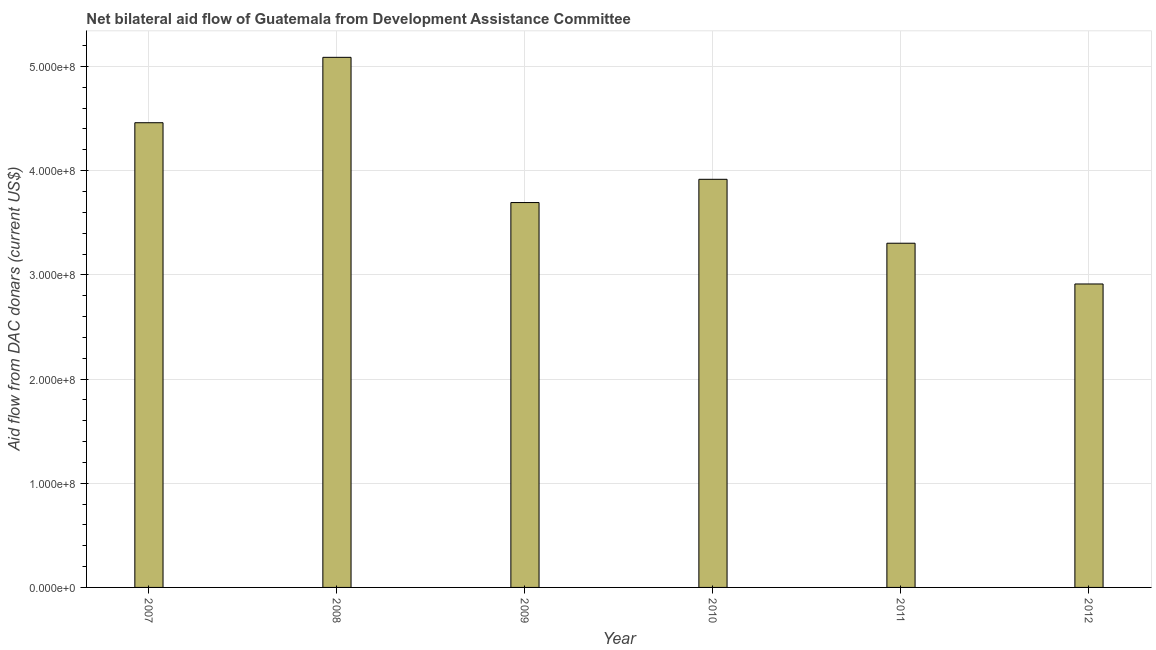What is the title of the graph?
Provide a succinct answer. Net bilateral aid flow of Guatemala from Development Assistance Committee. What is the label or title of the X-axis?
Your answer should be very brief. Year. What is the label or title of the Y-axis?
Offer a terse response. Aid flow from DAC donars (current US$). What is the net bilateral aid flows from dac donors in 2010?
Provide a short and direct response. 3.92e+08. Across all years, what is the maximum net bilateral aid flows from dac donors?
Make the answer very short. 5.09e+08. Across all years, what is the minimum net bilateral aid flows from dac donors?
Offer a very short reply. 2.91e+08. In which year was the net bilateral aid flows from dac donors maximum?
Provide a succinct answer. 2008. What is the sum of the net bilateral aid flows from dac donors?
Offer a terse response. 2.34e+09. What is the difference between the net bilateral aid flows from dac donors in 2008 and 2010?
Make the answer very short. 1.17e+08. What is the average net bilateral aid flows from dac donors per year?
Your answer should be compact. 3.90e+08. What is the median net bilateral aid flows from dac donors?
Provide a succinct answer. 3.81e+08. In how many years, is the net bilateral aid flows from dac donors greater than 120000000 US$?
Your response must be concise. 6. Do a majority of the years between 2008 and 2011 (inclusive) have net bilateral aid flows from dac donors greater than 140000000 US$?
Your response must be concise. Yes. What is the ratio of the net bilateral aid flows from dac donors in 2007 to that in 2011?
Keep it short and to the point. 1.35. Is the net bilateral aid flows from dac donors in 2007 less than that in 2009?
Your response must be concise. No. What is the difference between the highest and the second highest net bilateral aid flows from dac donors?
Provide a succinct answer. 6.28e+07. Is the sum of the net bilateral aid flows from dac donors in 2008 and 2009 greater than the maximum net bilateral aid flows from dac donors across all years?
Make the answer very short. Yes. What is the difference between the highest and the lowest net bilateral aid flows from dac donors?
Provide a short and direct response. 2.18e+08. How many bars are there?
Provide a short and direct response. 6. Are all the bars in the graph horizontal?
Your answer should be compact. No. What is the difference between two consecutive major ticks on the Y-axis?
Your answer should be compact. 1.00e+08. Are the values on the major ticks of Y-axis written in scientific E-notation?
Ensure brevity in your answer.  Yes. What is the Aid flow from DAC donars (current US$) in 2007?
Make the answer very short. 4.46e+08. What is the Aid flow from DAC donars (current US$) of 2008?
Offer a terse response. 5.09e+08. What is the Aid flow from DAC donars (current US$) in 2009?
Offer a very short reply. 3.69e+08. What is the Aid flow from DAC donars (current US$) in 2010?
Your response must be concise. 3.92e+08. What is the Aid flow from DAC donars (current US$) in 2011?
Offer a very short reply. 3.30e+08. What is the Aid flow from DAC donars (current US$) of 2012?
Give a very brief answer. 2.91e+08. What is the difference between the Aid flow from DAC donars (current US$) in 2007 and 2008?
Keep it short and to the point. -6.28e+07. What is the difference between the Aid flow from DAC donars (current US$) in 2007 and 2009?
Offer a very short reply. 7.66e+07. What is the difference between the Aid flow from DAC donars (current US$) in 2007 and 2010?
Provide a short and direct response. 5.43e+07. What is the difference between the Aid flow from DAC donars (current US$) in 2007 and 2011?
Offer a terse response. 1.16e+08. What is the difference between the Aid flow from DAC donars (current US$) in 2007 and 2012?
Offer a terse response. 1.55e+08. What is the difference between the Aid flow from DAC donars (current US$) in 2008 and 2009?
Your response must be concise. 1.39e+08. What is the difference between the Aid flow from DAC donars (current US$) in 2008 and 2010?
Your answer should be compact. 1.17e+08. What is the difference between the Aid flow from DAC donars (current US$) in 2008 and 2011?
Your answer should be very brief. 1.78e+08. What is the difference between the Aid flow from DAC donars (current US$) in 2008 and 2012?
Your response must be concise. 2.18e+08. What is the difference between the Aid flow from DAC donars (current US$) in 2009 and 2010?
Keep it short and to the point. -2.23e+07. What is the difference between the Aid flow from DAC donars (current US$) in 2009 and 2011?
Provide a short and direct response. 3.90e+07. What is the difference between the Aid flow from DAC donars (current US$) in 2009 and 2012?
Your response must be concise. 7.81e+07. What is the difference between the Aid flow from DAC donars (current US$) in 2010 and 2011?
Make the answer very short. 6.14e+07. What is the difference between the Aid flow from DAC donars (current US$) in 2010 and 2012?
Offer a very short reply. 1.00e+08. What is the difference between the Aid flow from DAC donars (current US$) in 2011 and 2012?
Your response must be concise. 3.91e+07. What is the ratio of the Aid flow from DAC donars (current US$) in 2007 to that in 2008?
Make the answer very short. 0.88. What is the ratio of the Aid flow from DAC donars (current US$) in 2007 to that in 2009?
Ensure brevity in your answer.  1.21. What is the ratio of the Aid flow from DAC donars (current US$) in 2007 to that in 2010?
Provide a succinct answer. 1.14. What is the ratio of the Aid flow from DAC donars (current US$) in 2007 to that in 2011?
Provide a short and direct response. 1.35. What is the ratio of the Aid flow from DAC donars (current US$) in 2007 to that in 2012?
Give a very brief answer. 1.53. What is the ratio of the Aid flow from DAC donars (current US$) in 2008 to that in 2009?
Provide a short and direct response. 1.38. What is the ratio of the Aid flow from DAC donars (current US$) in 2008 to that in 2010?
Ensure brevity in your answer.  1.3. What is the ratio of the Aid flow from DAC donars (current US$) in 2008 to that in 2011?
Provide a short and direct response. 1.54. What is the ratio of the Aid flow from DAC donars (current US$) in 2008 to that in 2012?
Your response must be concise. 1.75. What is the ratio of the Aid flow from DAC donars (current US$) in 2009 to that in 2010?
Provide a short and direct response. 0.94. What is the ratio of the Aid flow from DAC donars (current US$) in 2009 to that in 2011?
Keep it short and to the point. 1.12. What is the ratio of the Aid flow from DAC donars (current US$) in 2009 to that in 2012?
Ensure brevity in your answer.  1.27. What is the ratio of the Aid flow from DAC donars (current US$) in 2010 to that in 2011?
Your answer should be very brief. 1.19. What is the ratio of the Aid flow from DAC donars (current US$) in 2010 to that in 2012?
Offer a very short reply. 1.34. What is the ratio of the Aid flow from DAC donars (current US$) in 2011 to that in 2012?
Give a very brief answer. 1.13. 